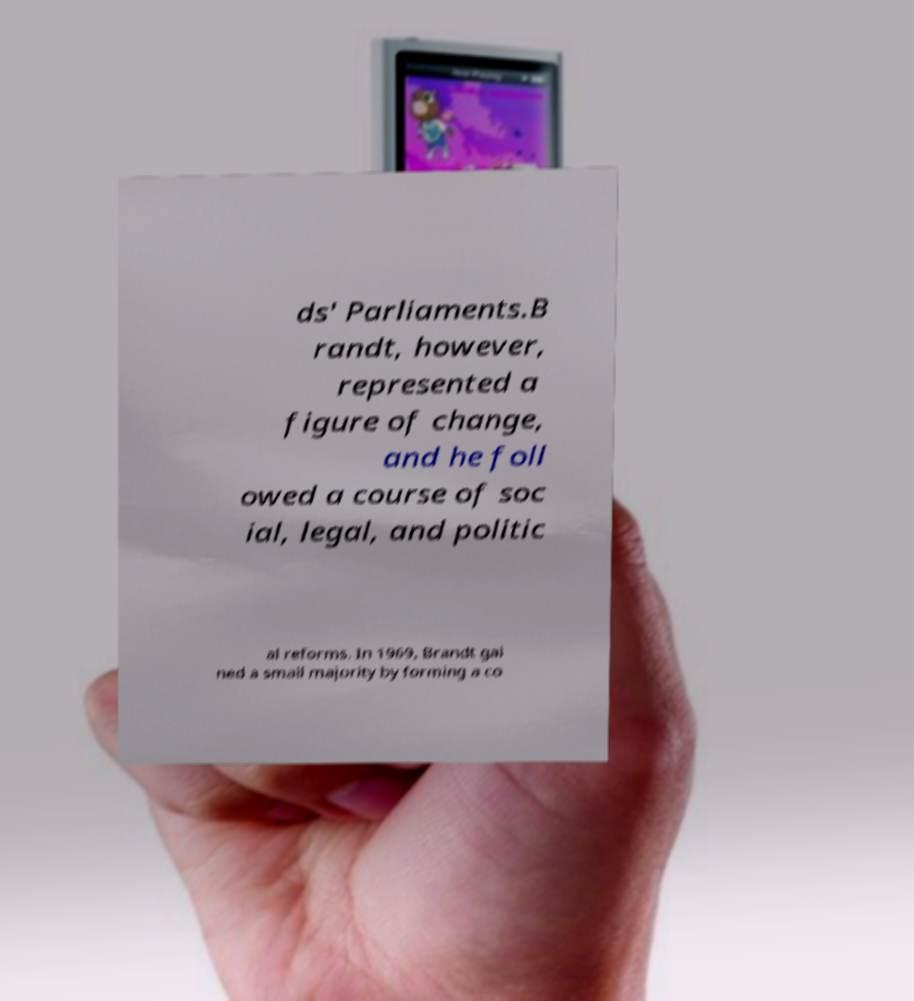There's text embedded in this image that I need extracted. Can you transcribe it verbatim? ds' Parliaments.B randt, however, represented a figure of change, and he foll owed a course of soc ial, legal, and politic al reforms. In 1969, Brandt gai ned a small majority by forming a co 